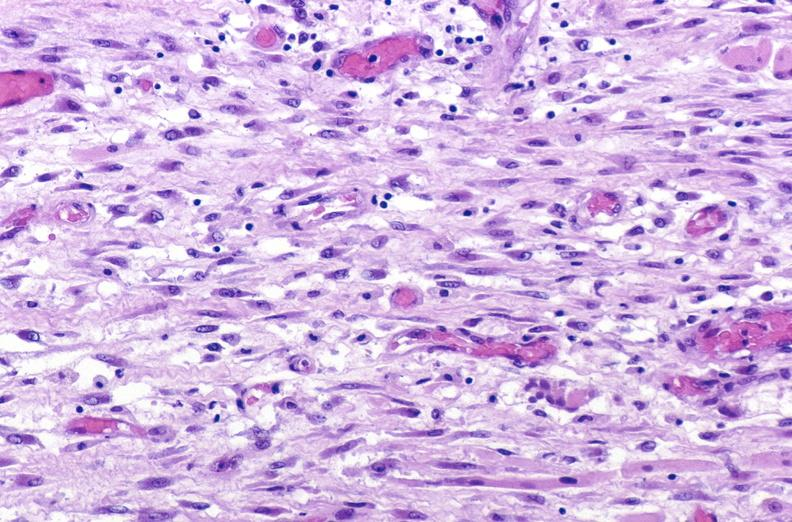s soft tissue present?
Answer the question using a single word or phrase. Yes 